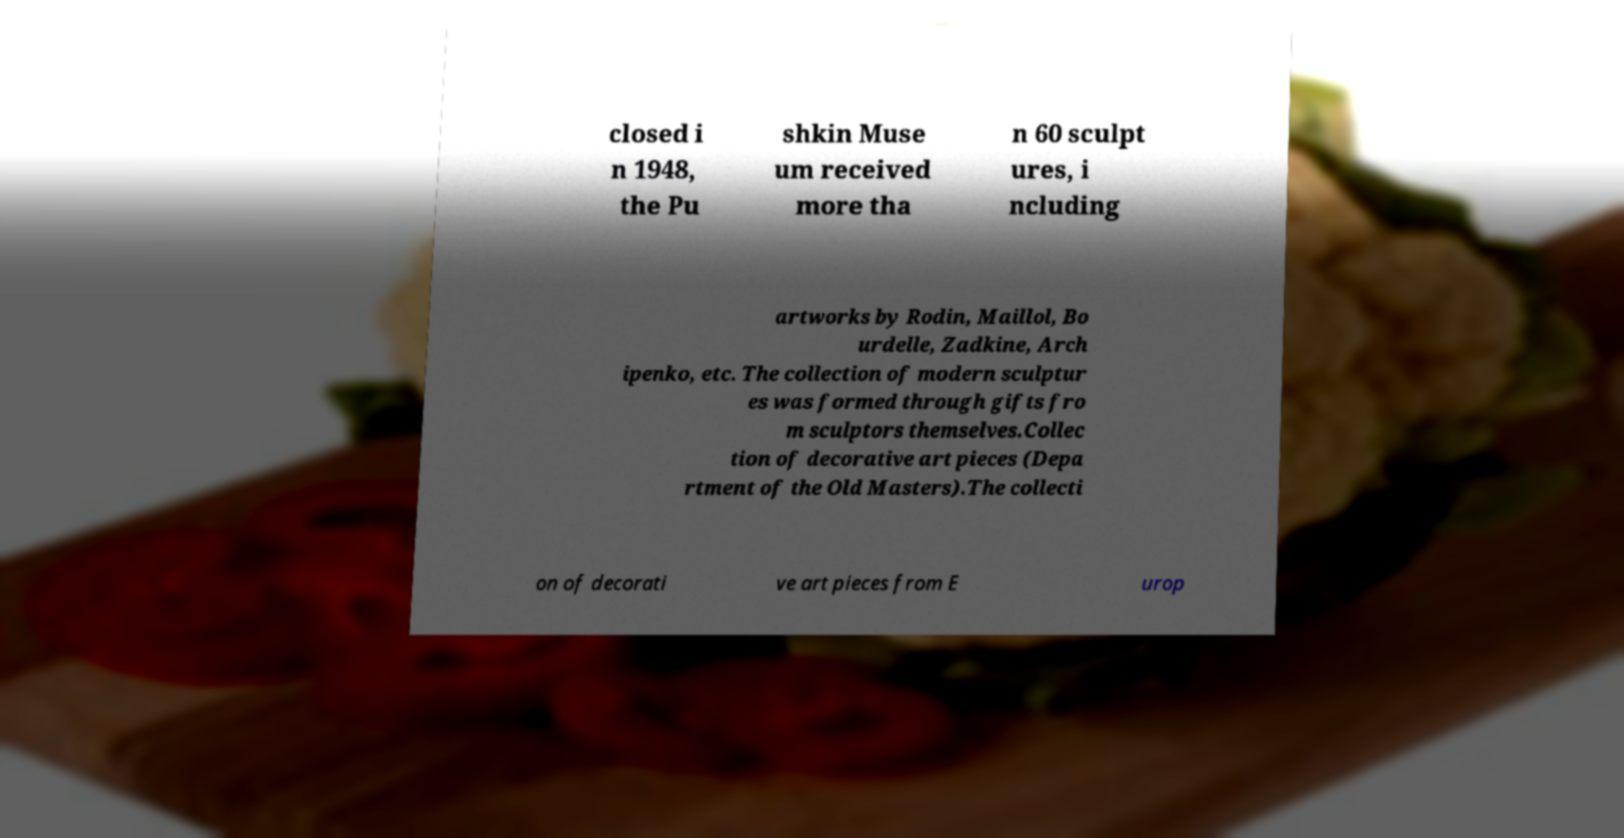Can you read and provide the text displayed in the image?This photo seems to have some interesting text. Can you extract and type it out for me? closed i n 1948, the Pu shkin Muse um received more tha n 60 sculpt ures, i ncluding artworks by Rodin, Maillol, Bo urdelle, Zadkine, Arch ipenko, etc. The collection of modern sculptur es was formed through gifts fro m sculptors themselves.Collec tion of decorative art pieces (Depa rtment of the Old Masters).The collecti on of decorati ve art pieces from E urop 